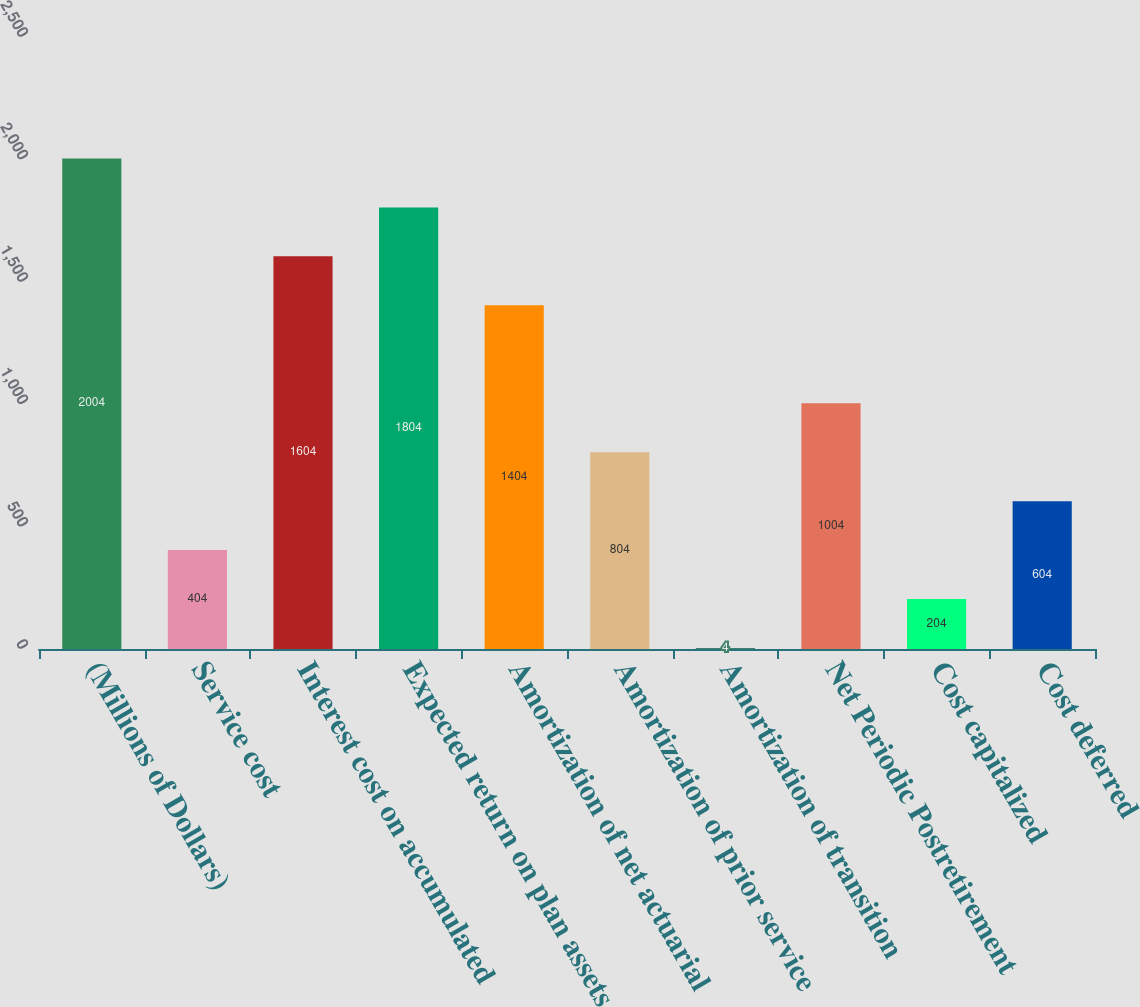Convert chart to OTSL. <chart><loc_0><loc_0><loc_500><loc_500><bar_chart><fcel>(Millions of Dollars)<fcel>Service cost<fcel>Interest cost on accumulated<fcel>Expected return on plan assets<fcel>Amortization of net actuarial<fcel>Amortization of prior service<fcel>Amortization of transition<fcel>Net Periodic Postretirement<fcel>Cost capitalized<fcel>Cost deferred<nl><fcel>2004<fcel>404<fcel>1604<fcel>1804<fcel>1404<fcel>804<fcel>4<fcel>1004<fcel>204<fcel>604<nl></chart> 